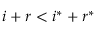<formula> <loc_0><loc_0><loc_500><loc_500>i + r < i ^ { * } + r ^ { * }</formula> 